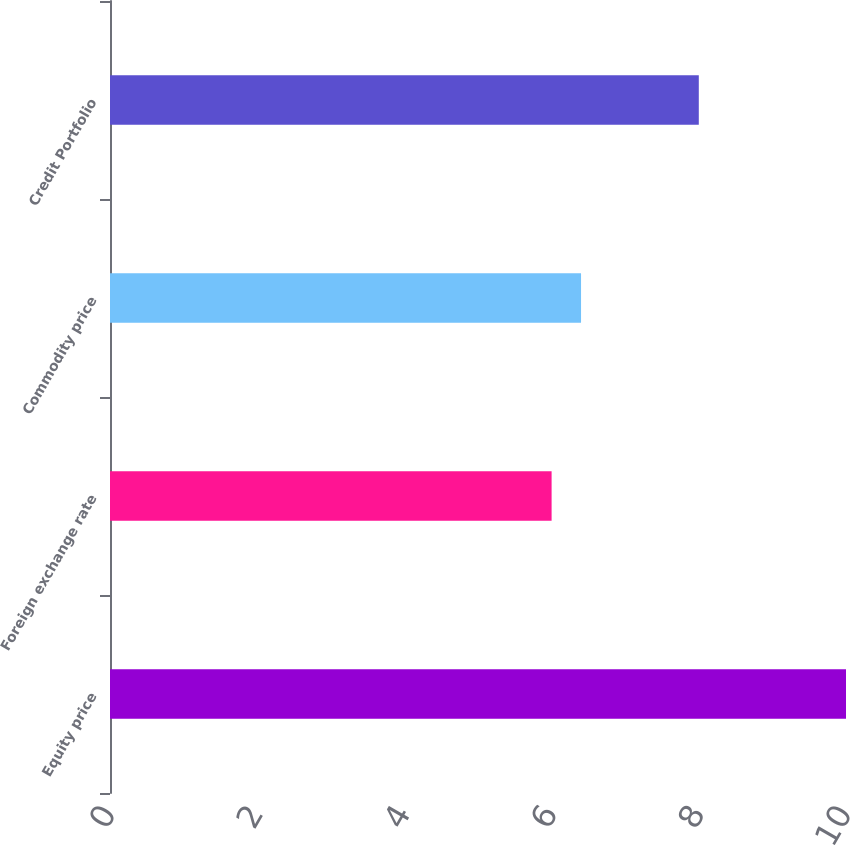Convert chart to OTSL. <chart><loc_0><loc_0><loc_500><loc_500><bar_chart><fcel>Equity price<fcel>Foreign exchange rate<fcel>Commodity price<fcel>Credit Portfolio<nl><fcel>10<fcel>6<fcel>6.4<fcel>8<nl></chart> 